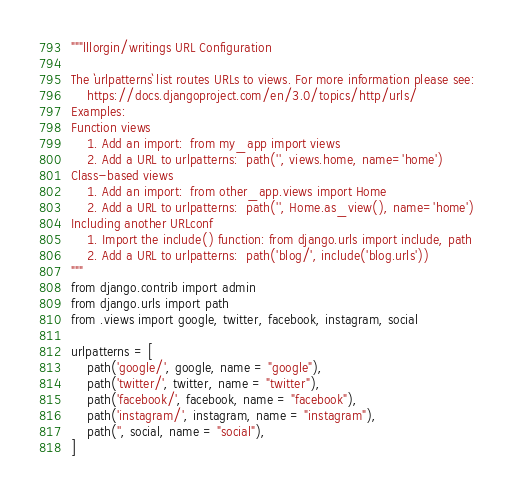Convert code to text. <code><loc_0><loc_0><loc_500><loc_500><_Python_>"""lllorgin/writings URL Configuration

The `urlpatterns` list routes URLs to views. For more information please see:
    https://docs.djangoproject.com/en/3.0/topics/http/urls/
Examples:
Function views
    1. Add an import:  from my_app import views
    2. Add a URL to urlpatterns:  path('', views.home, name='home')
Class-based views
    1. Add an import:  from other_app.views import Home
    2. Add a URL to urlpatterns:  path('', Home.as_view(), name='home')
Including another URLconf
    1. Import the include() function: from django.urls import include, path
    2. Add a URL to urlpatterns:  path('blog/', include('blog.urls'))
"""
from django.contrib import admin
from django.urls import path
from .views import google, twitter, facebook, instagram, social

urlpatterns = [
    path('google/', google, name = "google"),
    path('twitter/', twitter, name = "twitter"),
    path('facebook/', facebook, name = "facebook"),
    path('instagram/', instagram, name = "instagram"),
    path('', social, name = "social"),
]
</code> 